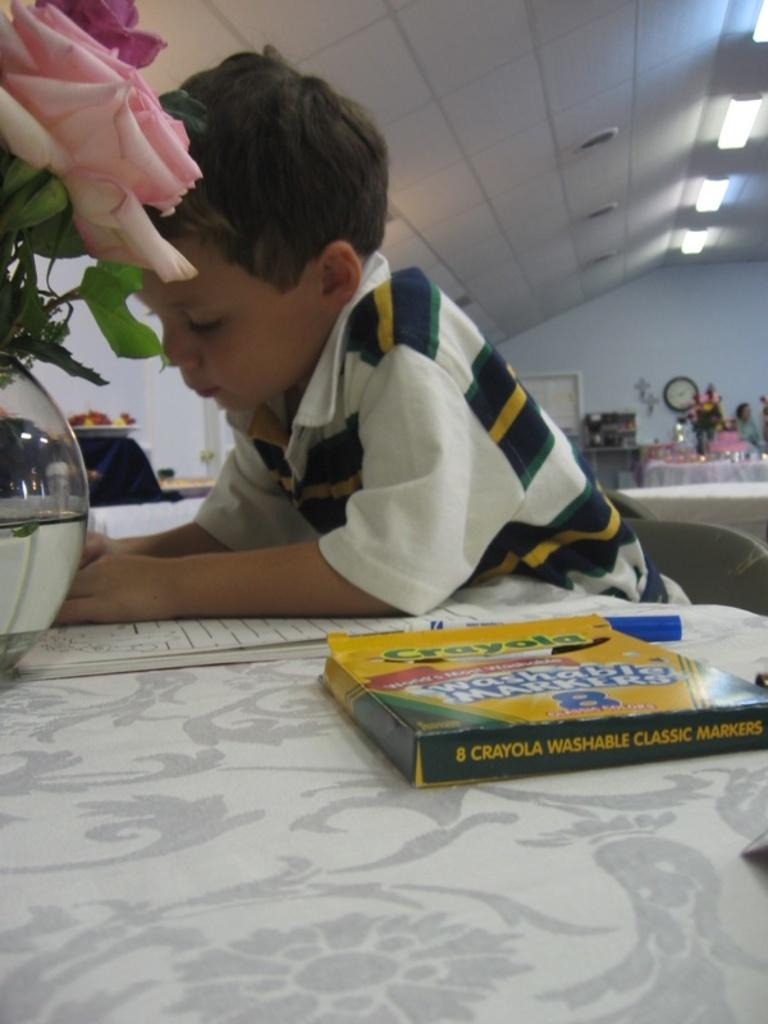What is the kid doing in the image? The kid is seated on a chair in the image. What items are on the table in front of the kid? There are books, a flower vase, and sketches on the table. What can be seen in the background of the image? There are lights visible in the background of the image. What type of vacation guide is the kid holding in the image? There is no vacation guide present in the image; the kid is seated on a chair with books and sketches on the table. 